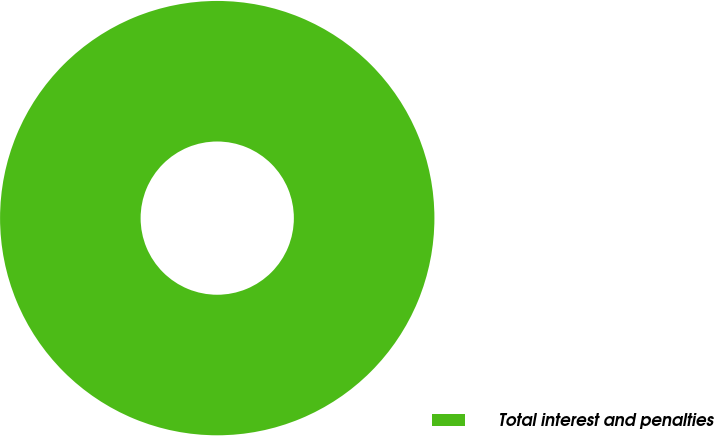<chart> <loc_0><loc_0><loc_500><loc_500><pie_chart><fcel>Total interest and penalties<nl><fcel>100.0%<nl></chart> 